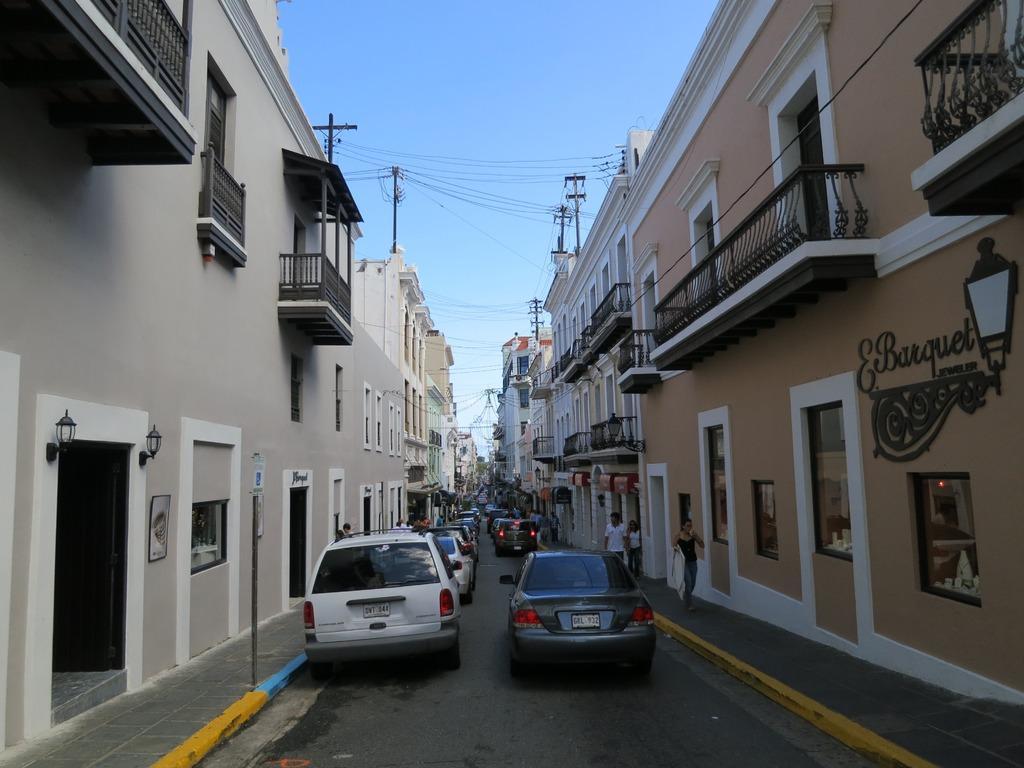How would you summarize this image in a sentence or two? In this image I can see many vehicles on the road. On both sides of the road I can see the buildings, boards and the lights. I can also see few people. In the background I can see the sky. 